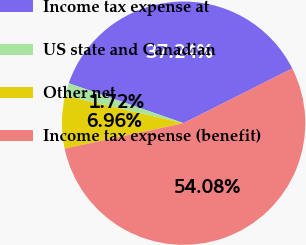Convert chart. <chart><loc_0><loc_0><loc_500><loc_500><pie_chart><fcel>Income tax expense at<fcel>US state and Canadian<fcel>Other net<fcel>Income tax expense (benefit)<nl><fcel>37.24%<fcel>1.72%<fcel>6.96%<fcel>54.07%<nl></chart> 